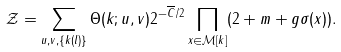Convert formula to latex. <formula><loc_0><loc_0><loc_500><loc_500>\mathcal { Z } = \sum _ { u , v , \{ k ( l ) \} } \Theta ( k ; u , v ) 2 ^ { - \overline { C } / 2 } \prod _ { x \in \mathcal { M } [ k ] } ( 2 + m + g \sigma ( x ) ) .</formula> 